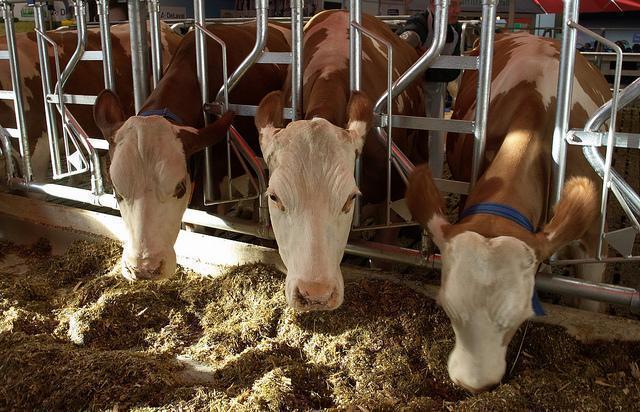Why are the animals putting their face to the ground?
Choose the correct response, then elucidate: 'Answer: answer
Rationale: rationale.'
Options: To rest, to sleep, to eat, to fight. Answer: to eat.
Rationale: The cows are awake and are not interacting with each other. 